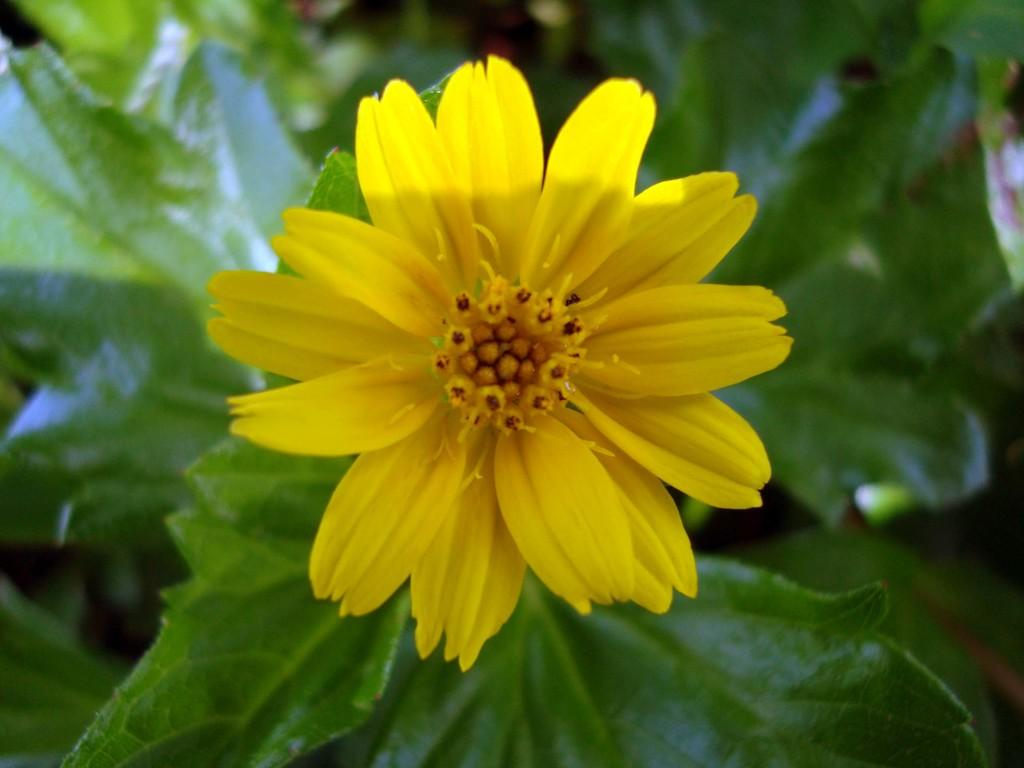What is the main subject of the image? There is a flower in the image. What color is the flower? The flower is yellow in color. Where is the flower located? The flower is on a plant. How much money does the flower have in the image? There is no indication of money in the image, as it features a yellow flower on a plant. 